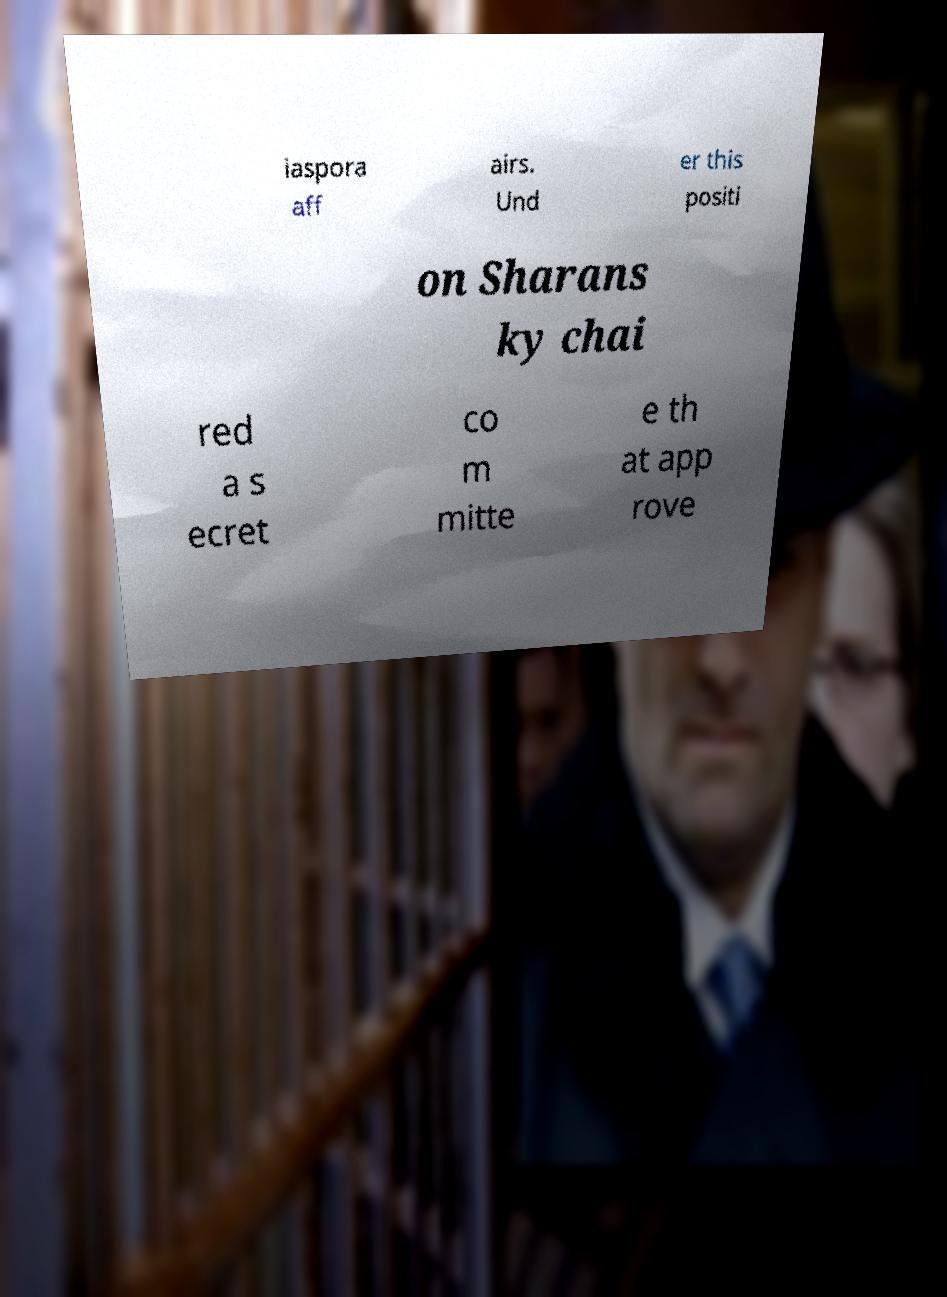There's text embedded in this image that I need extracted. Can you transcribe it verbatim? iaspora aff airs. Und er this positi on Sharans ky chai red a s ecret co m mitte e th at app rove 